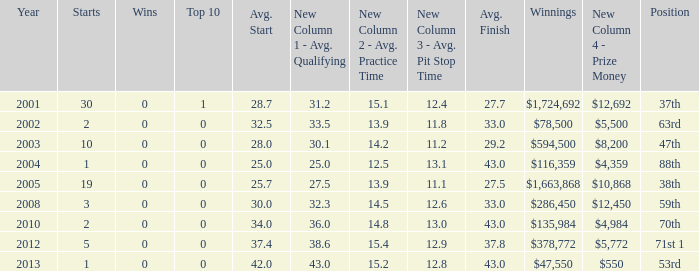What is the average top 10 score for 2 starts, winnings of $135,984 and an average finish more than 43? None. 